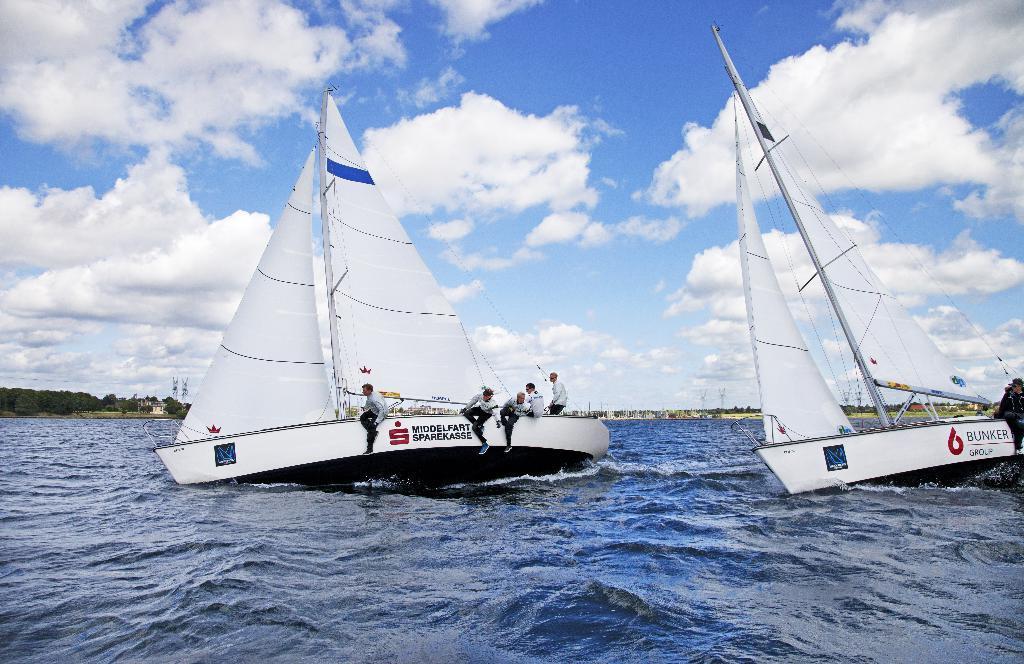How would you summarize this image in a sentence or two? At the bottom of the image on the water there are boats with poles, ropes, clothes and also there are names on the boats. And there are few people sitting in the boats. Behind them there are trees. At the top of the image there is sky with clouds. 